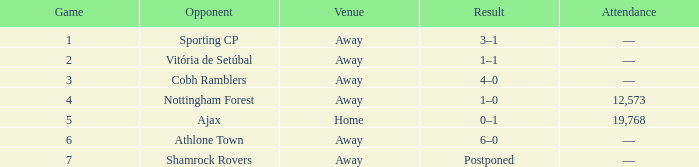What is the total game number with athlone town as the opponent? 1.0. 